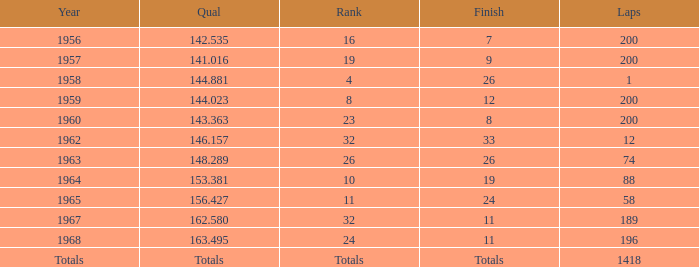Which qual features 200 aggregate laps and happened in 1957? 141.016. 